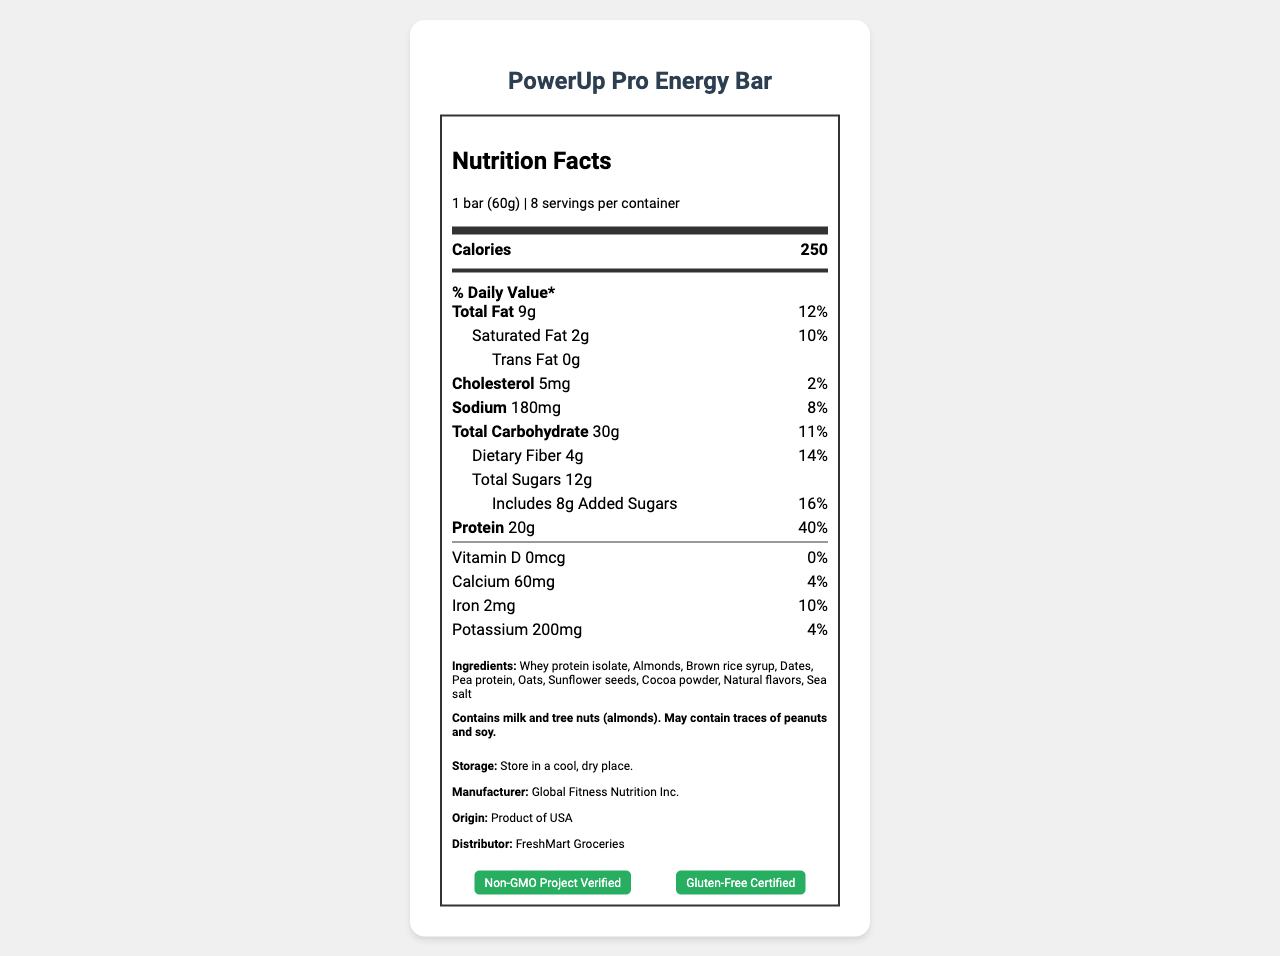what is the serving size of the PowerUp Pro Energy Bar? The serving size is indicated directly under the product name in the "serving info" section.
Answer: 1 bar (60g) how many calories are in one bar? The number of calories per bar is listed under "Calories" in bold.
Answer: 250 what is the total fat content per serving? The total fat content per serving is found in the "Total Fat" section, listed as 9g.
Answer: 9g how much protein does one serving contain? The protein content per serving is specified in the "Protein" section, listed as 20g.
Answer: 20g what percentage of the daily recommended value of dietary fiber does one bar provide? The daily value percentage for dietary fiber is listed in the "Dietary Fiber" section as 14%.
Answer: 14% which ingredients are listed first on the ingredient list? The first three ingredients listed under "Ingredients" are Whey protein isolate, Almonds, and Brown rice syrup.
Answer: Whey protein isolate, Almonds, Brown rice syrup what is the daily value percentage of calcium in one bar? The daily value percentage of calcium is listed as 4% in the "Calcium" section.
Answer: 4% how much cholesterol is in one serving? The cholesterol content per serving is listed as 5mg in the "Cholesterol" section.
Answer: 5mg how should the PowerUp Pro Energy Bar be stored? The storage instructions are provided under "Storage" as "Store in a cool, dry place."
Answer: Store in a cool, dry place. who distributes the PowerUp Pro Energy Bar? The distributor is listed under "Distributor" as FreshMart Groceries.
Answer: FreshMart Groceries which certifications does the PowerUp Pro Energy Bar have? A. Organic B. Non-GMO Project Verified C. Gluten-Free Certified D. Both B and C The certifications listed include "Non-GMO Project Verified" and "Gluten-Free Certified".
Answer: D what percentage of daily value for sodium is provided by one bar? A. 2% B. 8% C. 10% D. 16% The daily value percentage for sodium is listed as 8% in the "Sodium" section.
Answer: B how much vitamin D does one serving provide? A. 0% B. 4% C. 10% The percentage of daily value for vitamin D is listed as 0%.
Answer: A does the PowerUp Pro Energy Bar contain any artificial preservatives? The product claims include "No artificial preservatives."
Answer: No does the bar contain any allergens? The allergen information states it contains milk and tree nuts (almonds) and may contain traces of peanuts and soy.
Answer: Yes describe the main idea of the Nutrition Facts Label for the PowerUp Pro Energy Bar. The document includes detailed nutrition facts, ingredient list, allergen information, storage instructions, manufacturer, country of origin, distributor, and certifications. It emphasizes high protein content and absence of artificial preservatives.
Answer: The PowerUp Pro Energy Bar is a high-energy snack designed for fitness enthusiasts and active individuals, containing 20g of protein, 250 calories, and key nutrients. It has certifications such as Non-GMO and Gluten-Free, and natural ingredients like whey protein isolate and almonds. what is the barcode for the PowerUp Pro Energy Bar? The barcode is not provided in the visual information on the document.
Answer: Not enough information 